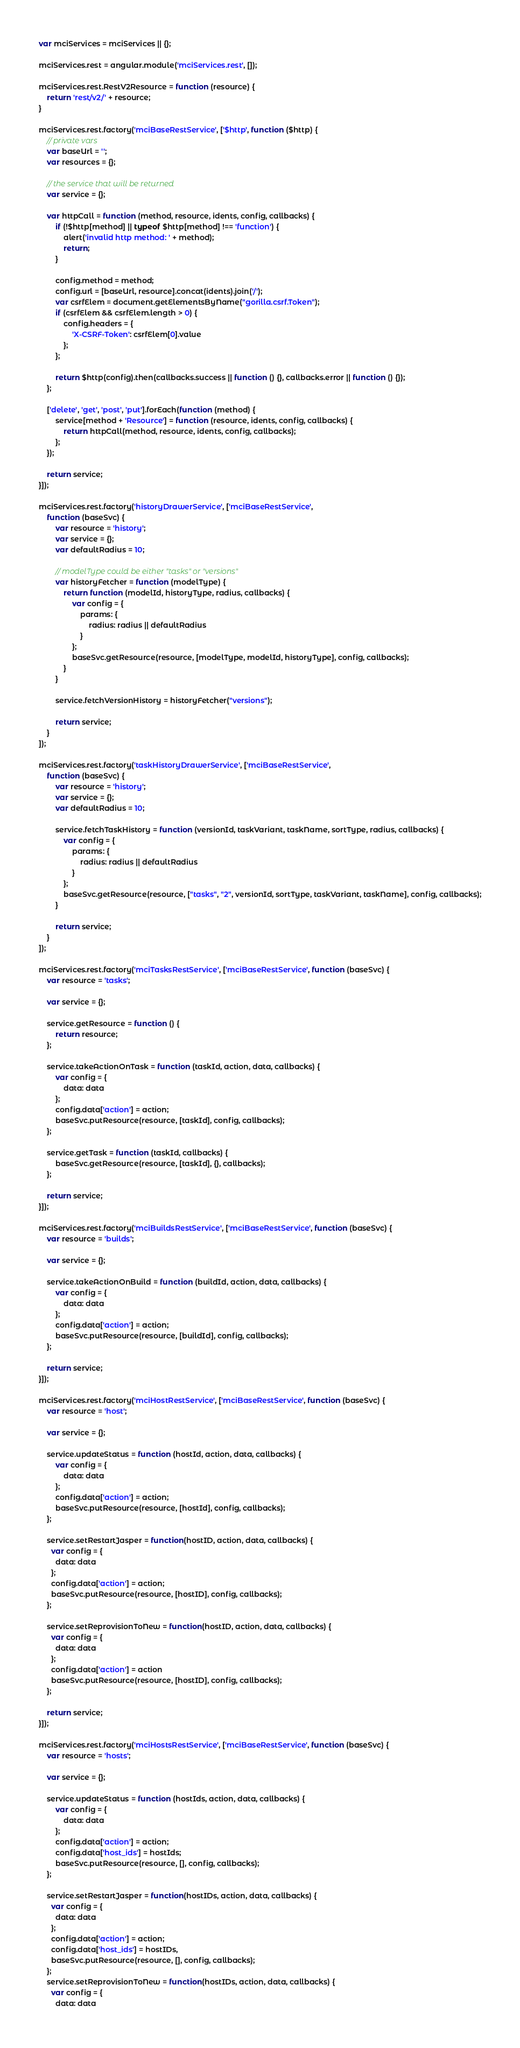<code> <loc_0><loc_0><loc_500><loc_500><_JavaScript_>var mciServices = mciServices || {};

mciServices.rest = angular.module('mciServices.rest', []);

mciServices.rest.RestV2Resource = function (resource) {
    return 'rest/v2/' + resource;
}

mciServices.rest.factory('mciBaseRestService', ['$http', function ($http) {
    // private vars
    var baseUrl = '';
    var resources = {};

    // the service that will be returned
    var service = {};

    var httpCall = function (method, resource, idents, config, callbacks) {
        if (!$http[method] || typeof $http[method] !== 'function') {
            alert('invalid http method: ' + method);
            return;
        }

        config.method = method;
        config.url = [baseUrl, resource].concat(idents).join('/');
        var csrfElem = document.getElementsByName("gorilla.csrf.Token");
        if (csrfElem && csrfElem.length > 0) {
            config.headers = {
                'X-CSRF-Token': csrfElem[0].value
            };
        };

        return $http(config).then(callbacks.success || function () {}, callbacks.error || function () {});
    };

    ['delete', 'get', 'post', 'put'].forEach(function (method) {
        service[method + 'Resource'] = function (resource, idents, config, callbacks) {
            return httpCall(method, resource, idents, config, callbacks);
        };
    });

    return service;
}]);

mciServices.rest.factory('historyDrawerService', ['mciBaseRestService',
    function (baseSvc) {
        var resource = 'history';
        var service = {};
        var defaultRadius = 10;

        // modelType could be either "tasks" or "versions"
        var historyFetcher = function (modelType) {
            return function (modelId, historyType, radius, callbacks) {
                var config = {
                    params: {
                        radius: radius || defaultRadius
                    }
                };
                baseSvc.getResource(resource, [modelType, modelId, historyType], config, callbacks);
            }
        }

        service.fetchVersionHistory = historyFetcher("versions");

        return service;
    }
]);

mciServices.rest.factory('taskHistoryDrawerService', ['mciBaseRestService',
    function (baseSvc) {
        var resource = 'history';
        var service = {};
        var defaultRadius = 10;

        service.fetchTaskHistory = function (versionId, taskVariant, taskName, sortType, radius, callbacks) {
            var config = {
                params: {
                    radius: radius || defaultRadius
                }
            };
            baseSvc.getResource(resource, ["tasks", "2", versionId, sortType, taskVariant, taskName], config, callbacks);
        }

        return service;
    }
]);

mciServices.rest.factory('mciTasksRestService', ['mciBaseRestService', function (baseSvc) {
    var resource = 'tasks';

    var service = {};

    service.getResource = function () {
        return resource;
    };

    service.takeActionOnTask = function (taskId, action, data, callbacks) {
        var config = {
            data: data
        };
        config.data['action'] = action;
        baseSvc.putResource(resource, [taskId], config, callbacks);
    };

    service.getTask = function (taskId, callbacks) {
        baseSvc.getResource(resource, [taskId], {}, callbacks);
    };

    return service;
}]);

mciServices.rest.factory('mciBuildsRestService', ['mciBaseRestService', function (baseSvc) {
    var resource = 'builds';

    var service = {};

    service.takeActionOnBuild = function (buildId, action, data, callbacks) {
        var config = {
            data: data
        };
        config.data['action'] = action;
        baseSvc.putResource(resource, [buildId], config, callbacks);
    };

    return service;
}]);

mciServices.rest.factory('mciHostRestService', ['mciBaseRestService', function (baseSvc) {
    var resource = 'host';

    var service = {};

    service.updateStatus = function (hostId, action, data, callbacks) {
        var config = {
            data: data
        };
        config.data['action'] = action;
        baseSvc.putResource(resource, [hostId], config, callbacks);
    };

    service.setRestartJasper = function(hostID, action, data, callbacks) {
      var config = {
        data: data
      };
      config.data['action'] = action;
      baseSvc.putResource(resource, [hostID], config, callbacks);
    };

    service.setReprovisionToNew = function(hostID, action, data, callbacks) {
      var config = {
        data: data
      };
      config.data['action'] = action
      baseSvc.putResource(resource, [hostID], config, callbacks);
    };

    return service;
}]);

mciServices.rest.factory('mciHostsRestService', ['mciBaseRestService', function (baseSvc) {
    var resource = 'hosts';

    var service = {};

    service.updateStatus = function (hostIds, action, data, callbacks) {
        var config = {
            data: data
        };
        config.data['action'] = action;
        config.data['host_ids'] = hostIds;
        baseSvc.putResource(resource, [], config, callbacks);
    };

    service.setRestartJasper = function(hostIDs, action, data, callbacks) {
      var config = {
        data: data
      };
      config.data['action'] = action;
      config.data['host_ids'] = hostIDs,
      baseSvc.putResource(resource, [], config, callbacks);
    };
    service.setReprovisionToNew = function(hostIDs, action, data, callbacks) {
      var config = {
        data: data</code> 